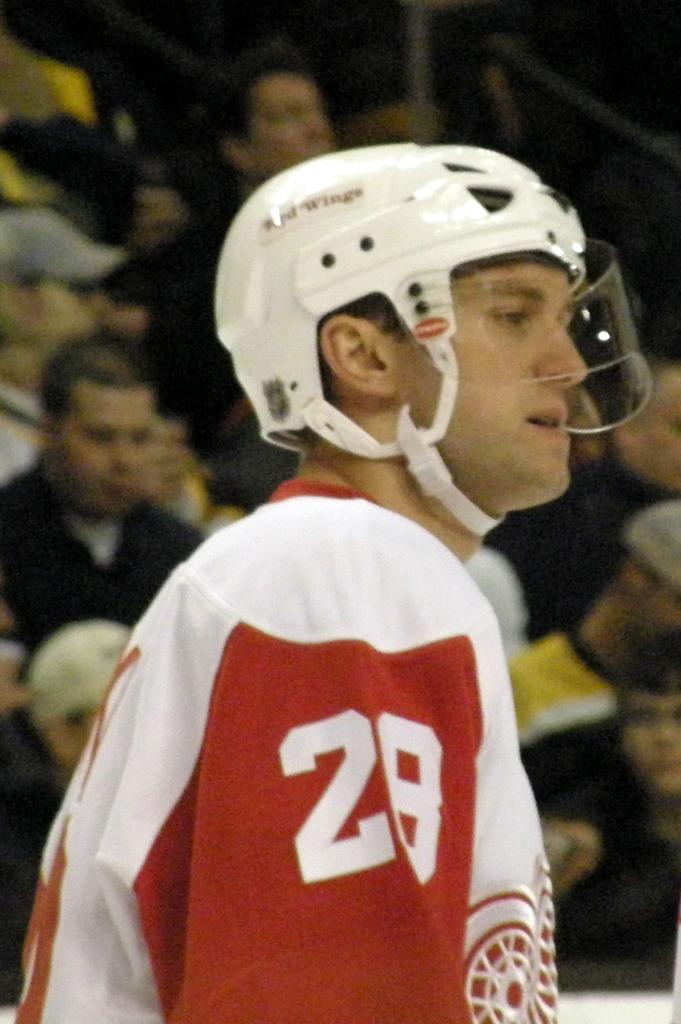Describe this image in one or two sentences. In this image in the foreground there is one person who is wearing a helmet, and in the background there are a group of people. 